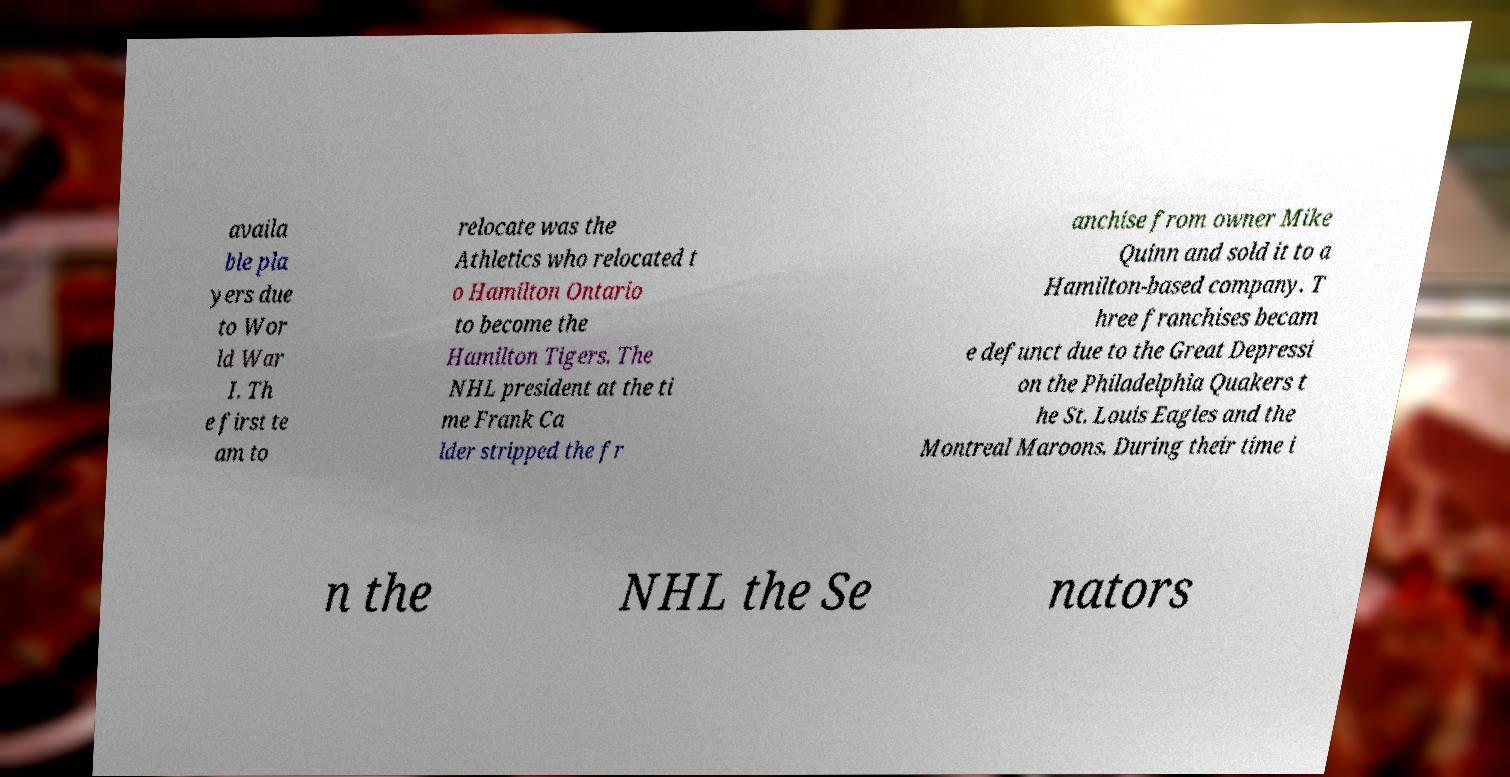For documentation purposes, I need the text within this image transcribed. Could you provide that? availa ble pla yers due to Wor ld War I. Th e first te am to relocate was the Athletics who relocated t o Hamilton Ontario to become the Hamilton Tigers. The NHL president at the ti me Frank Ca lder stripped the fr anchise from owner Mike Quinn and sold it to a Hamilton-based company. T hree franchises becam e defunct due to the Great Depressi on the Philadelphia Quakers t he St. Louis Eagles and the Montreal Maroons. During their time i n the NHL the Se nators 